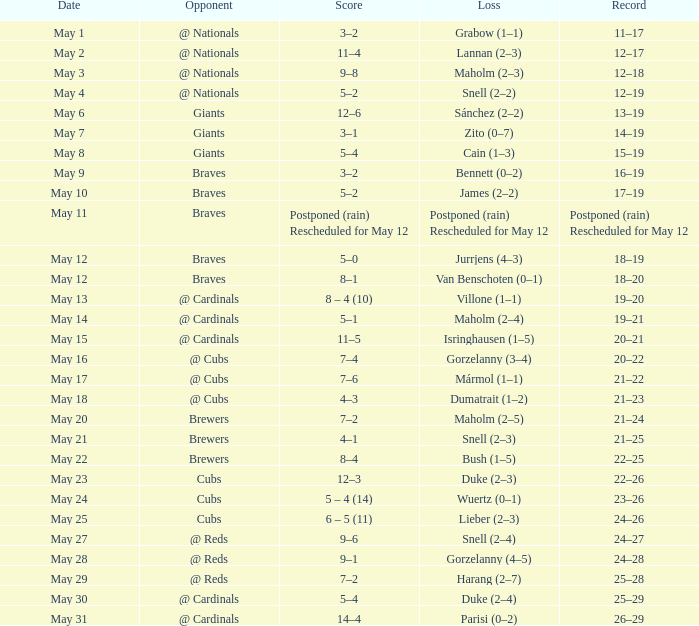What was the date of the game with a loss of Bush (1–5)? May 22. 